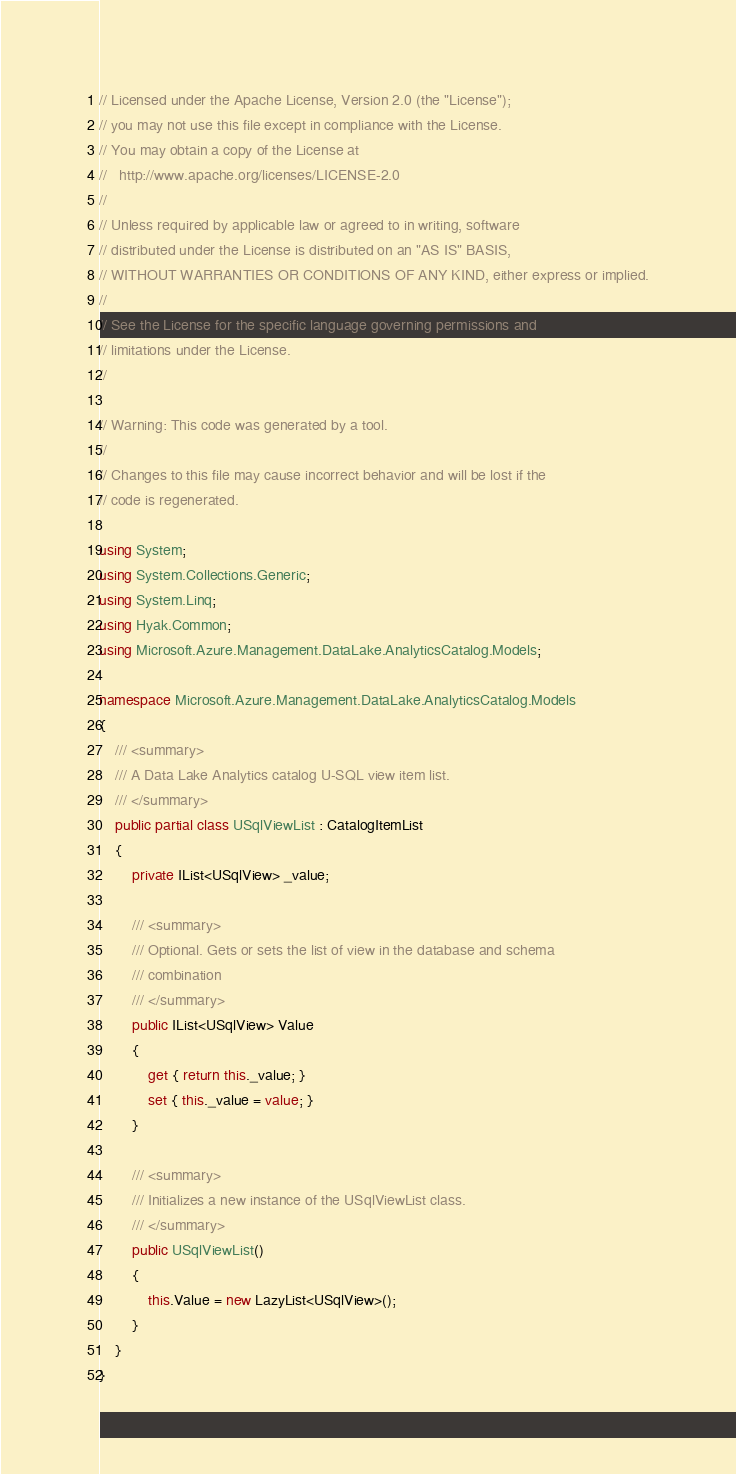Convert code to text. <code><loc_0><loc_0><loc_500><loc_500><_C#_>// Licensed under the Apache License, Version 2.0 (the "License");
// you may not use this file except in compliance with the License.
// You may obtain a copy of the License at
//   http://www.apache.org/licenses/LICENSE-2.0
// 
// Unless required by applicable law or agreed to in writing, software
// distributed under the License is distributed on an "AS IS" BASIS,
// WITHOUT WARRANTIES OR CONDITIONS OF ANY KIND, either express or implied.
// 
// See the License for the specific language governing permissions and
// limitations under the License.
// 

// Warning: This code was generated by a tool.
// 
// Changes to this file may cause incorrect behavior and will be lost if the
// code is regenerated.

using System;
using System.Collections.Generic;
using System.Linq;
using Hyak.Common;
using Microsoft.Azure.Management.DataLake.AnalyticsCatalog.Models;

namespace Microsoft.Azure.Management.DataLake.AnalyticsCatalog.Models
{
    /// <summary>
    /// A Data Lake Analytics catalog U-SQL view item list.
    /// </summary>
    public partial class USqlViewList : CatalogItemList
    {
        private IList<USqlView> _value;
        
        /// <summary>
        /// Optional. Gets or sets the list of view in the database and schema
        /// combination
        /// </summary>
        public IList<USqlView> Value
        {
            get { return this._value; }
            set { this._value = value; }
        }
        
        /// <summary>
        /// Initializes a new instance of the USqlViewList class.
        /// </summary>
        public USqlViewList()
        {
            this.Value = new LazyList<USqlView>();
        }
    }
}
</code> 